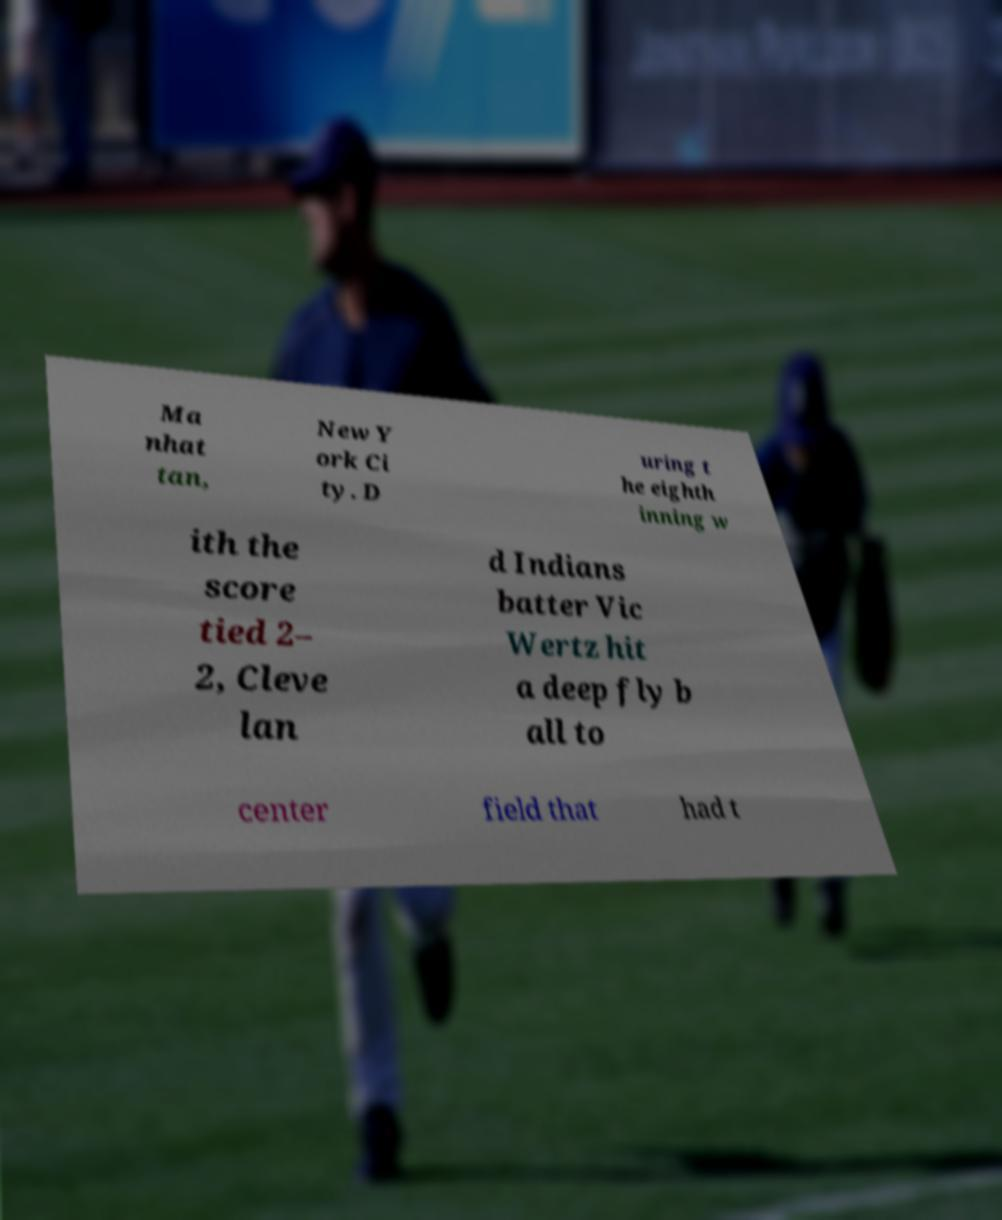Can you accurately transcribe the text from the provided image for me? Ma nhat tan, New Y ork Ci ty. D uring t he eighth inning w ith the score tied 2– 2, Cleve lan d Indians batter Vic Wertz hit a deep fly b all to center field that had t 